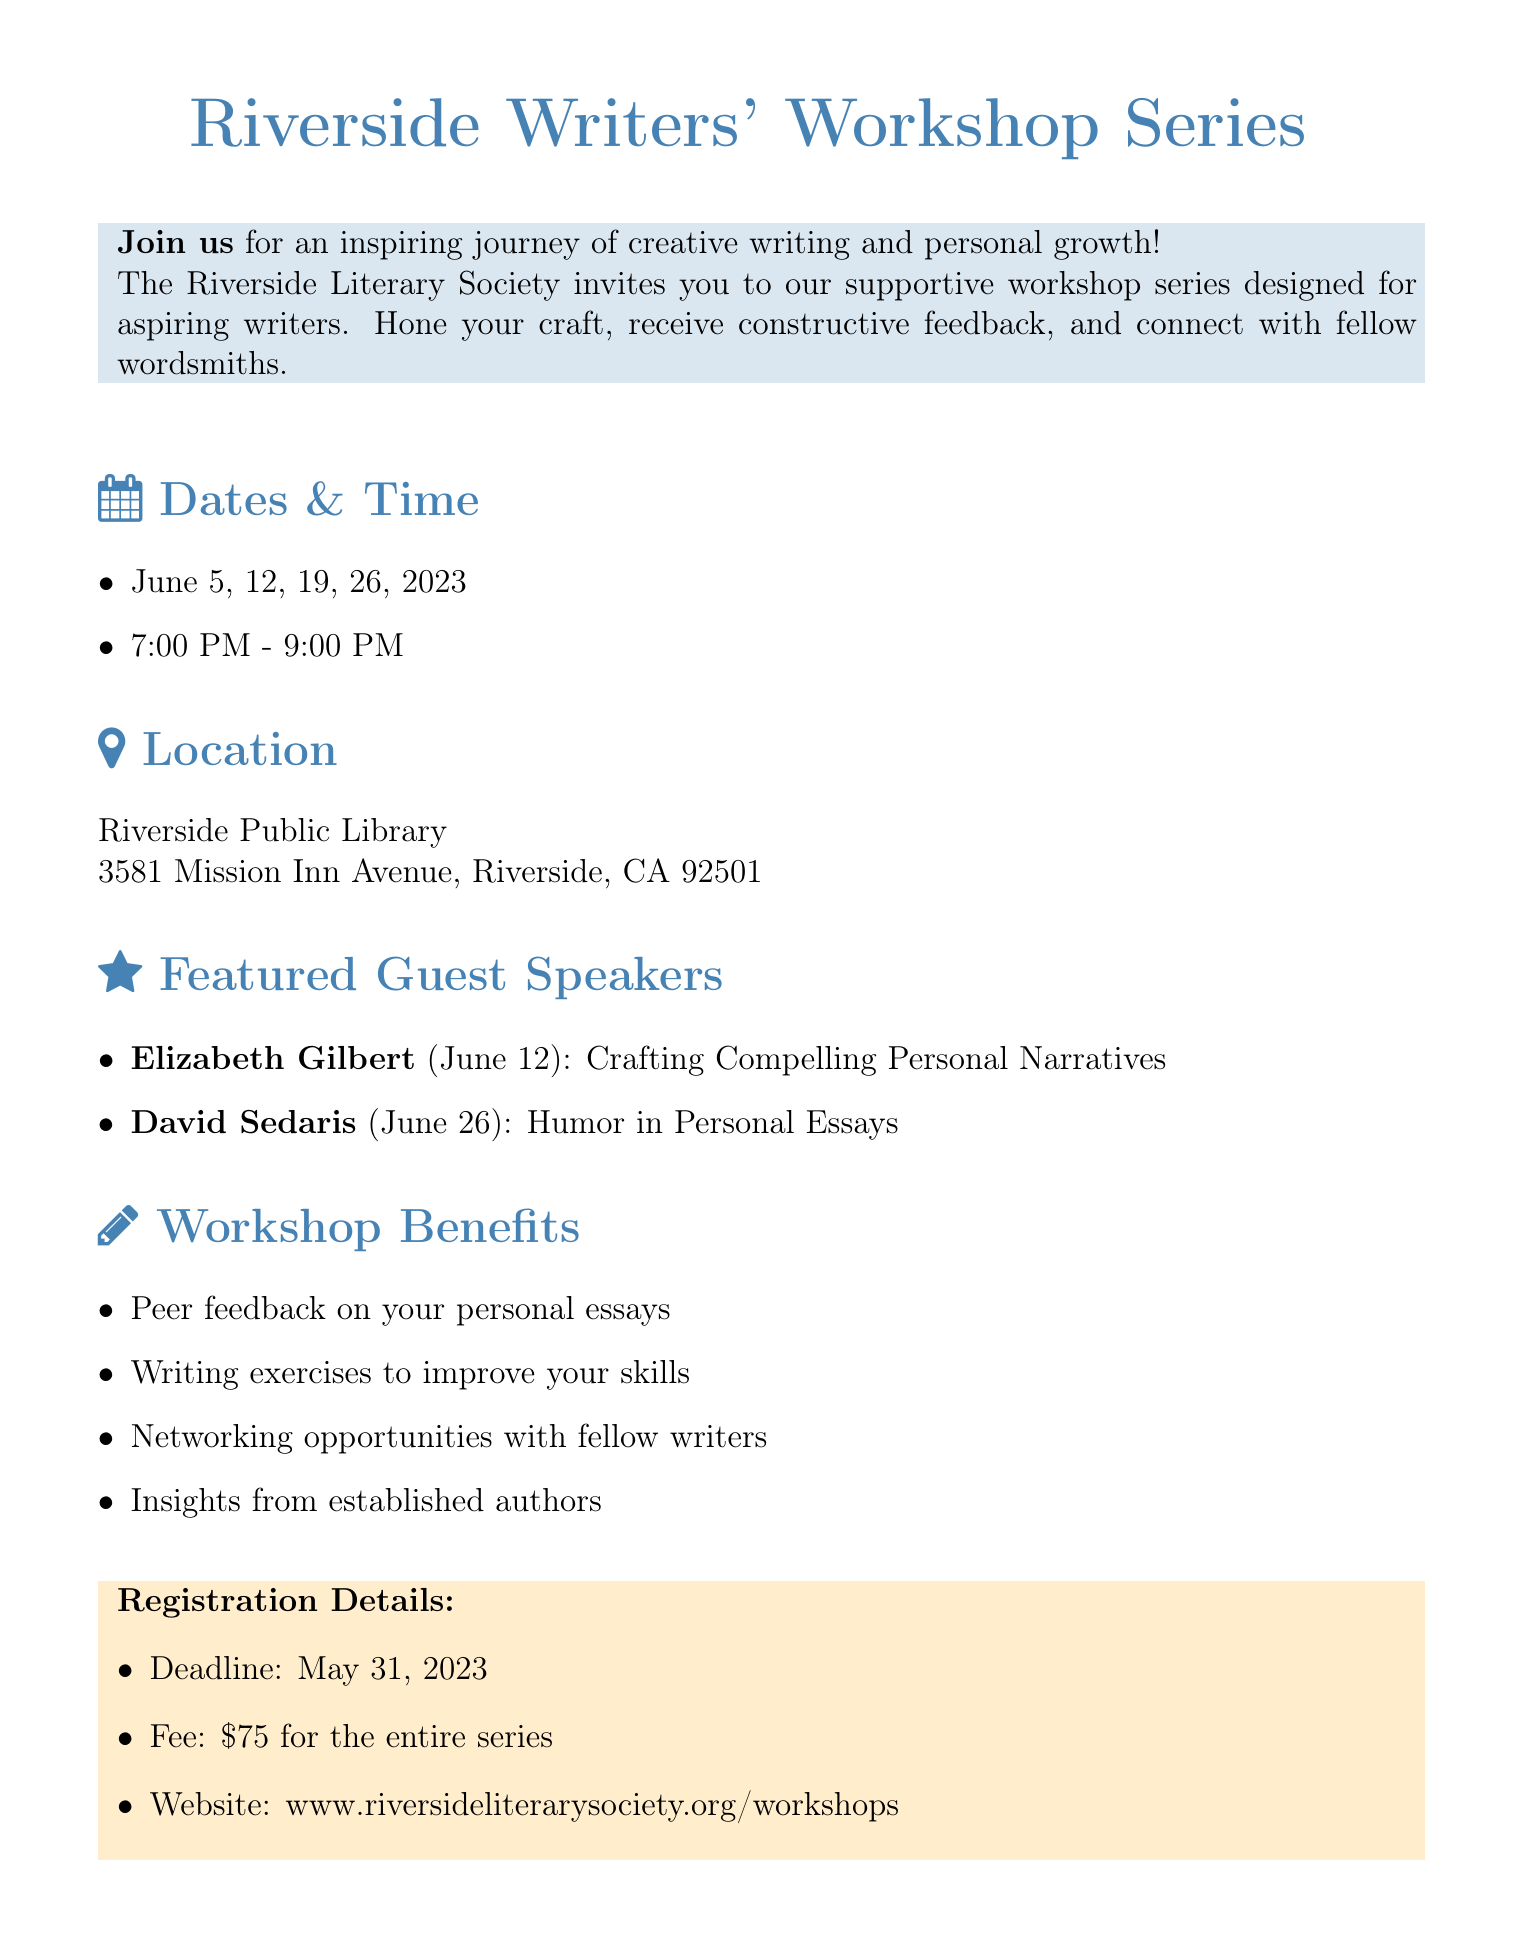what is the title of the workshop series? The title of the workshop series is provided at the beginning of the document: "Riverside Writers' Workshop Series".
Answer: Riverside Writers' Workshop Series who is the organizer of the workshop? The document states the organizer explicitly: "Riverside Literary Society".
Answer: Riverside Literary Society how many dates are there for the workshop series? The dates listed in the document are four, showing the total number of workshops: June 5, 12, 19, and 26, 2023.
Answer: 4 what time does the workshop start? The document specifies the start time: "7:00 PM".
Answer: 7:00 PM who is the guest speaker on June 26, 2023? The document lists David Sedaris as the guest speaker for the June 26 workshop.
Answer: David Sedaris what is the registration deadline? The document includes a specific date for registration, which is "May 31, 2023".
Answer: May 31, 2023 what is the fee for the entire series? The document mentions the fee required to register for the series as "$75".
Answer: $75 what benefit is related to peer feedback? The benefit related to peer feedback is described as "Peer feedback on your personal essays".
Answer: Peer feedback on your personal essays who should be contacted for more information? The contact information section specifies "Sarah Thompson" for inquiries.
Answer: Sarah Thompson 